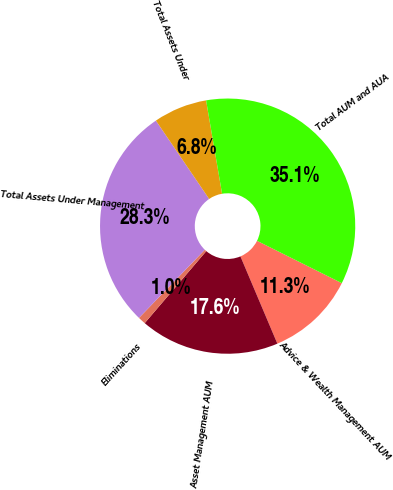Convert chart. <chart><loc_0><loc_0><loc_500><loc_500><pie_chart><fcel>Advice & Wealth Management AUM<fcel>Asset Management AUM<fcel>Eliminations<fcel>Total Assets Under Management<fcel>Total Assets Under<fcel>Total AUM and AUA<nl><fcel>11.26%<fcel>17.63%<fcel>0.97%<fcel>28.27%<fcel>6.8%<fcel>35.07%<nl></chart> 